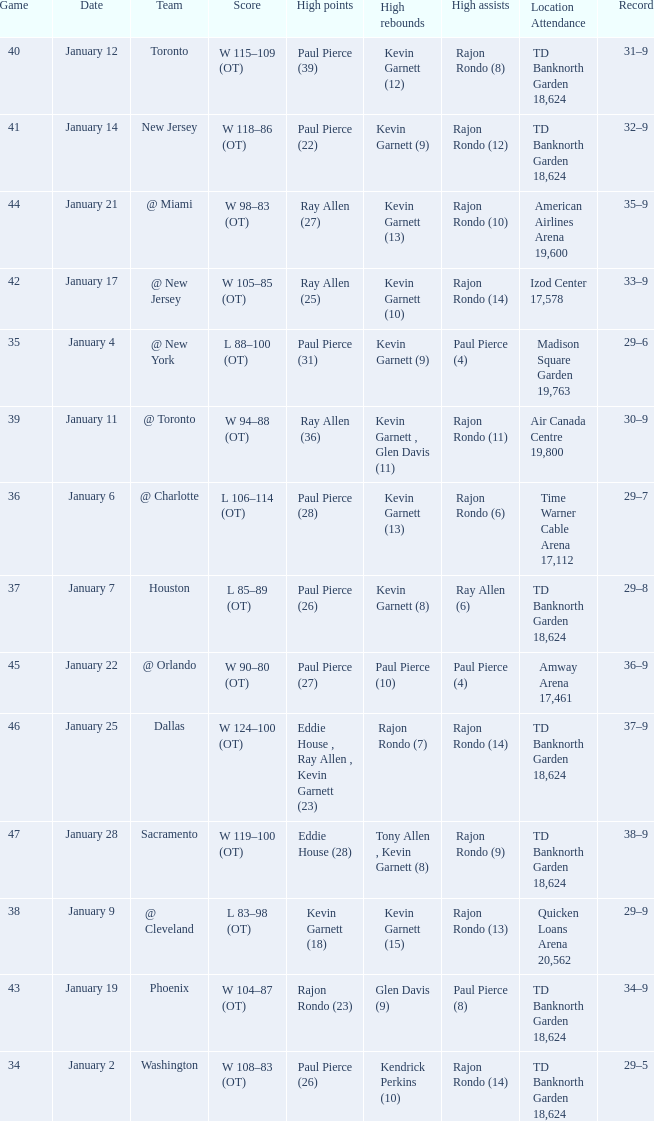Who had the high rebound total on january 6? Kevin Garnett (13). 